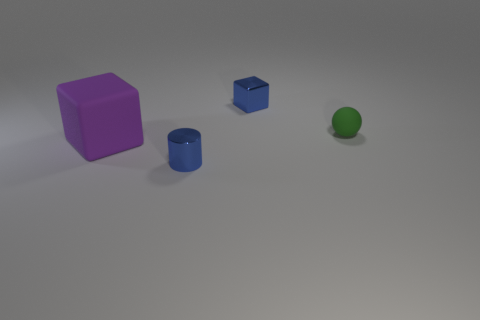There is a block that is behind the rubber ball; does it have the same color as the tiny thing that is in front of the purple rubber object?
Provide a short and direct response. Yes. There is a thing that is behind the purple rubber object and in front of the small metal cube; what is its material?
Keep it short and to the point. Rubber. What number of other things are there of the same color as the shiny cube?
Your answer should be very brief. 1. What number of other objects have the same shape as the large purple rubber object?
Keep it short and to the point. 1. There is a block that is the same material as the small green object; what size is it?
Provide a succinct answer. Large. Are there any matte objects that are behind the block that is on the left side of the small blue metallic object that is in front of the small blue metal block?
Your answer should be very brief. Yes. Do the block behind the ball and the big purple thing have the same size?
Offer a very short reply. No. How many purple matte blocks have the same size as the blue cylinder?
Your answer should be very brief. 0. The cylinder that is the same color as the metallic cube is what size?
Your answer should be very brief. Small. Is the tiny metallic block the same color as the tiny matte sphere?
Provide a succinct answer. No. 